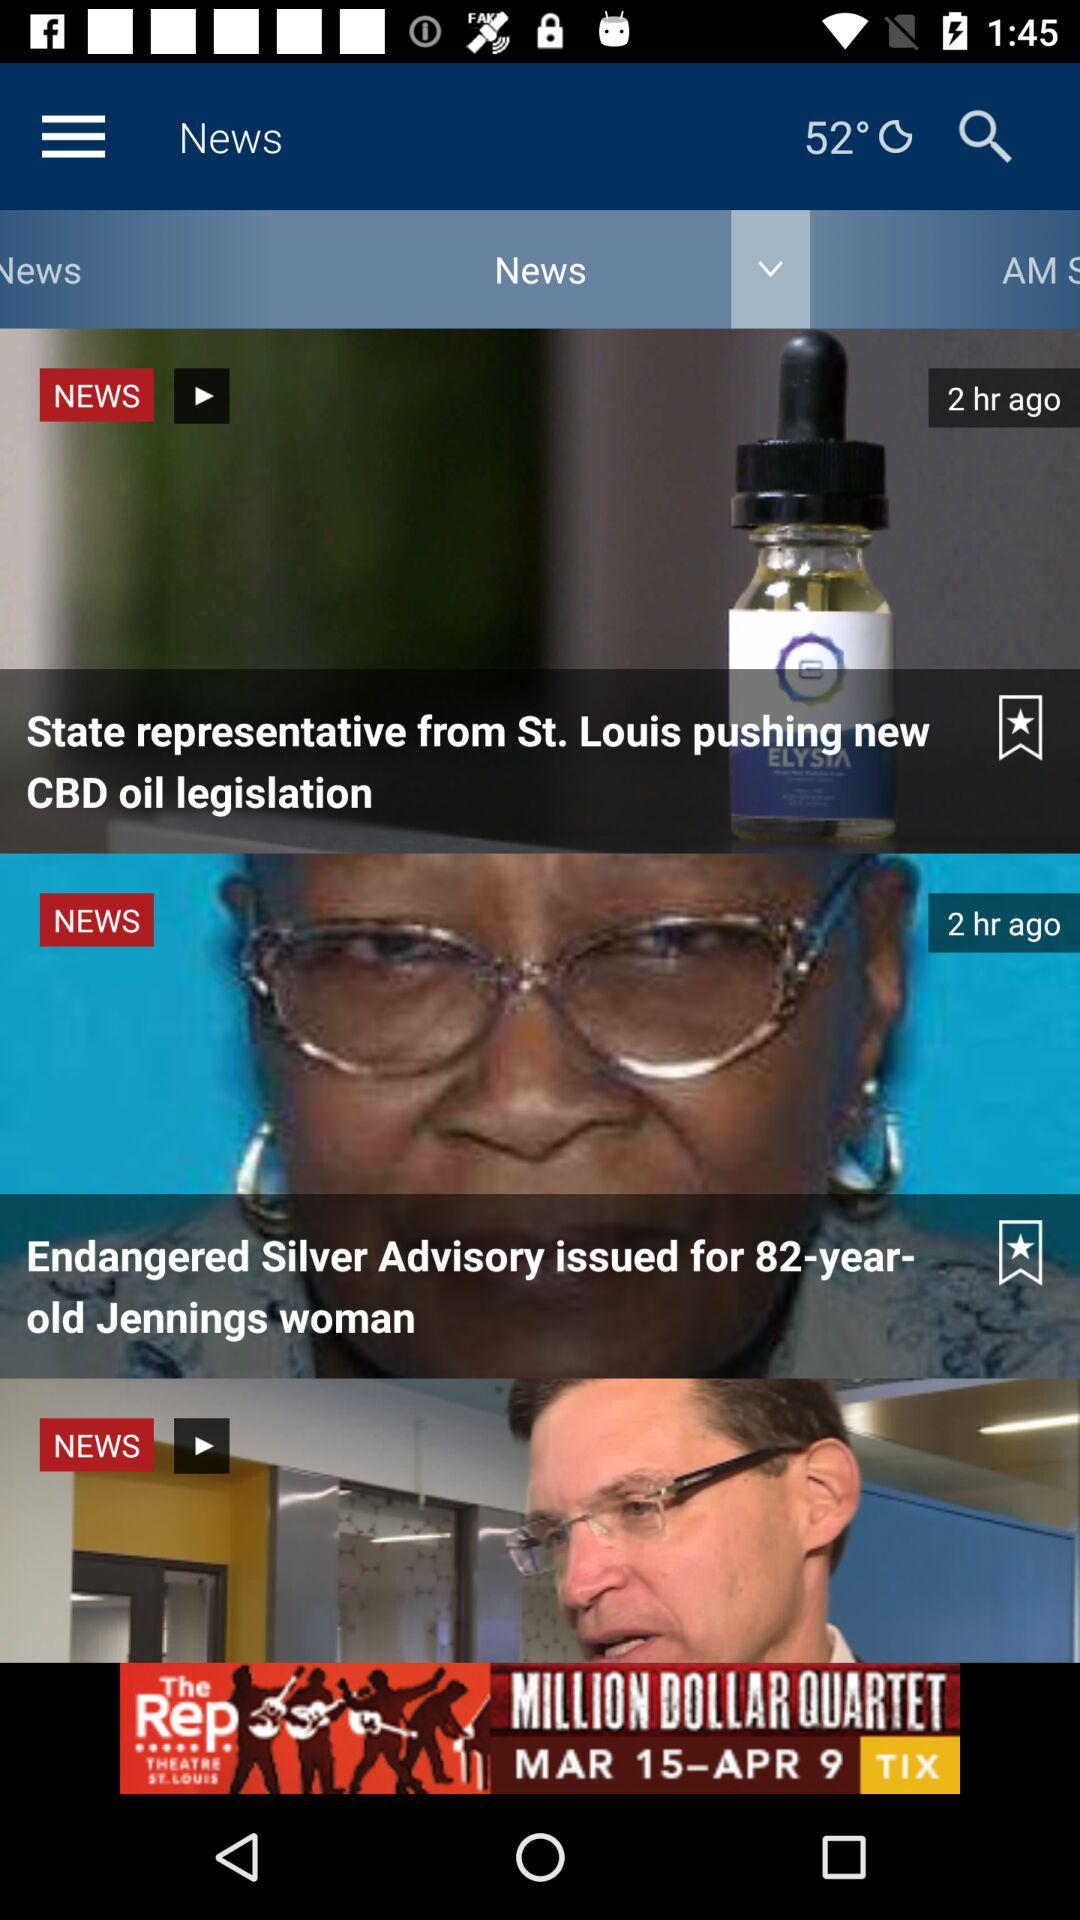How many hours ago was the "State representative from St. Louis pushing new CBD oil legislation" posted? The "State representative from St. Louis pushing new CBD oil legislation" was posted 2 hours ago. 